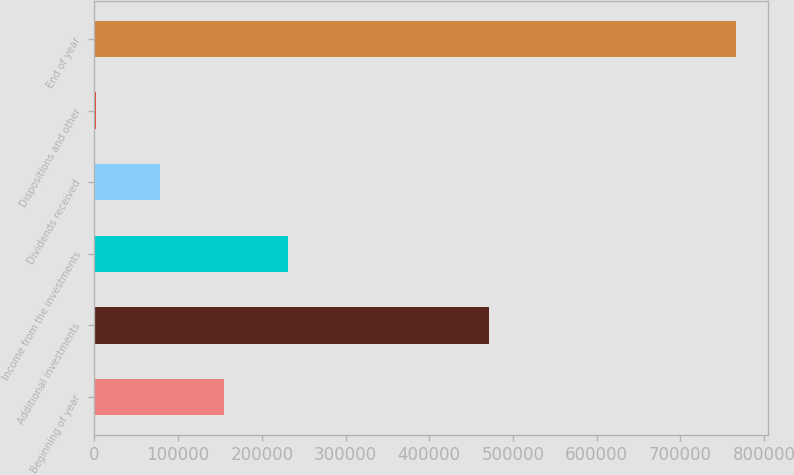<chart> <loc_0><loc_0><loc_500><loc_500><bar_chart><fcel>Beginning of year<fcel>Additional investments<fcel>Income from the investments<fcel>Dividends received<fcel>Dispositions and other<fcel>End of year<nl><fcel>154332<fcel>471102<fcel>230803<fcel>77860.4<fcel>1389<fcel>766103<nl></chart> 